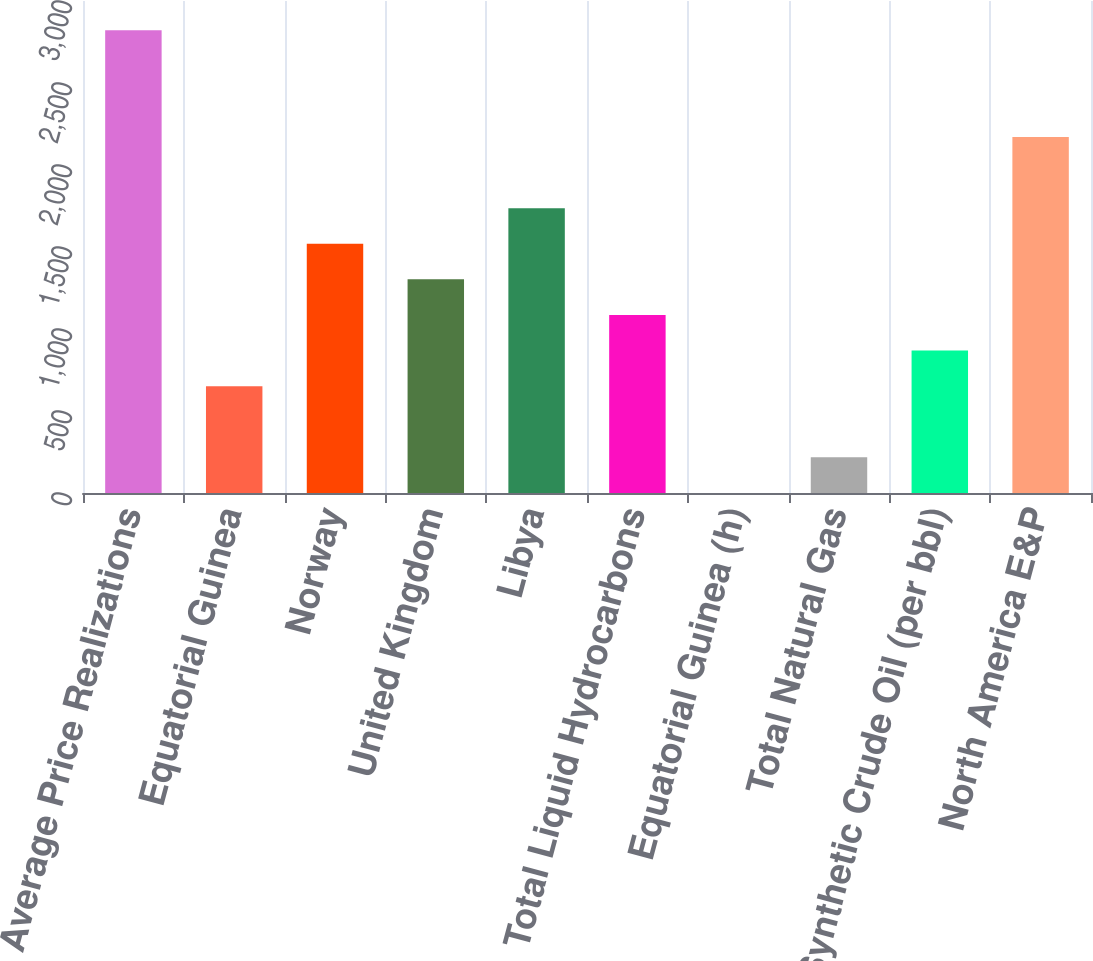Convert chart. <chart><loc_0><loc_0><loc_500><loc_500><bar_chart><fcel>Average Price Realizations<fcel>Equatorial Guinea<fcel>Norway<fcel>United Kingdom<fcel>Libya<fcel>Total Liquid Hydrocarbons<fcel>Equatorial Guinea (h)<fcel>Total Natural Gas<fcel>Synthetic Crude Oil (per bbl)<fcel>North America E&P<nl><fcel>2822.28<fcel>651.48<fcel>1519.8<fcel>1302.72<fcel>1736.88<fcel>1085.64<fcel>0.24<fcel>217.32<fcel>868.56<fcel>2171.04<nl></chart> 